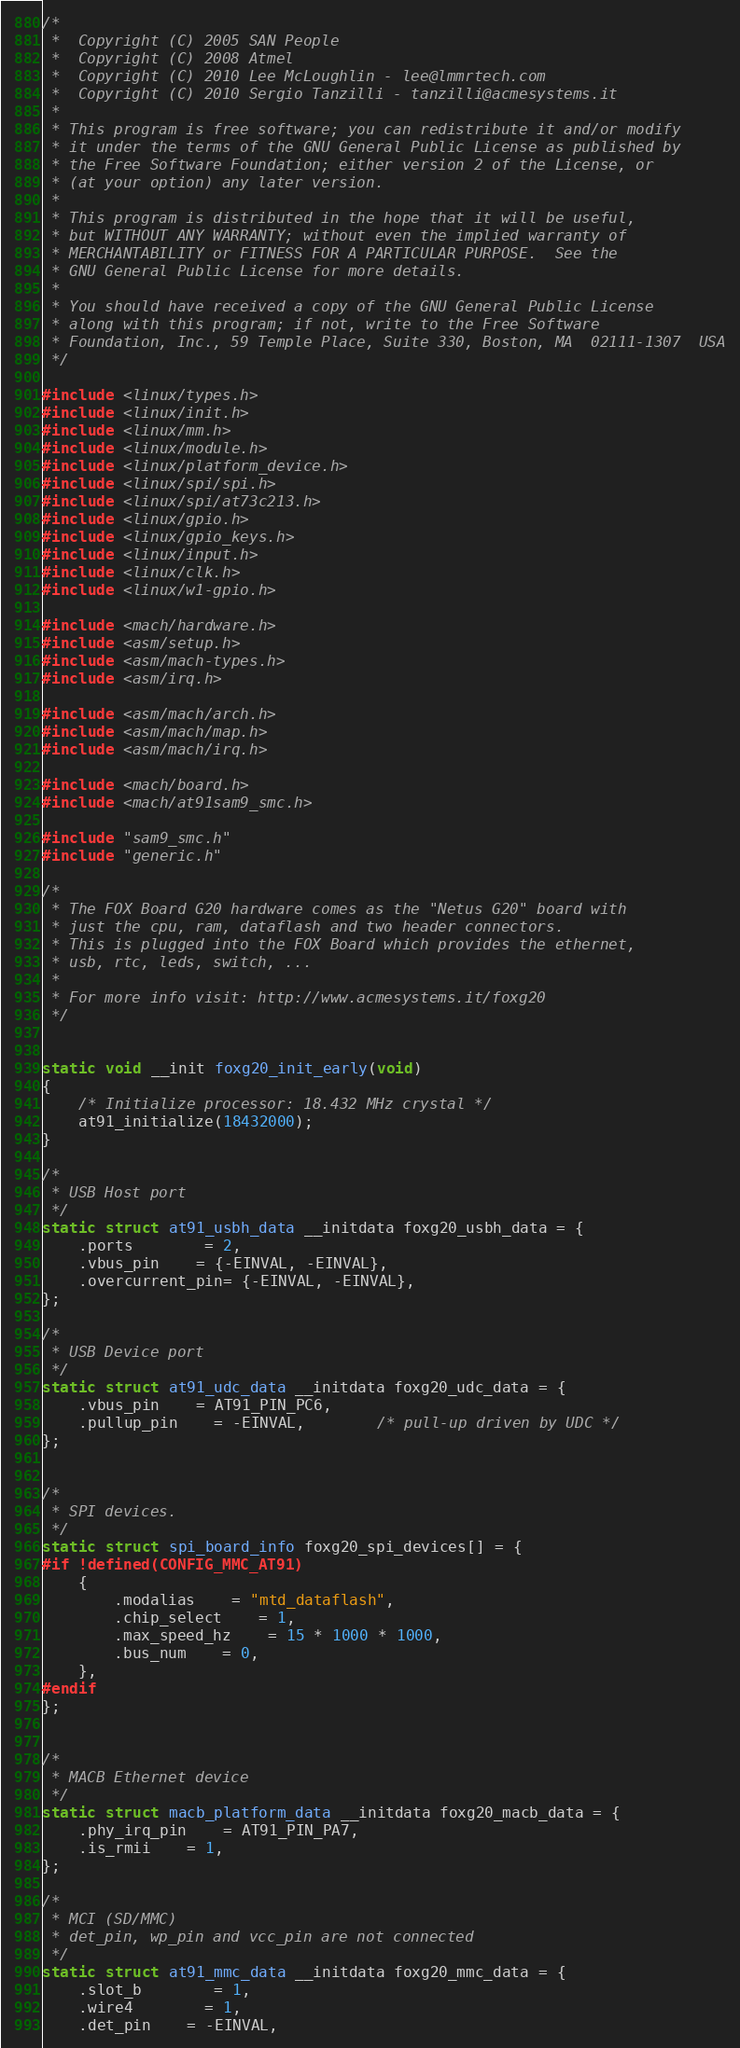<code> <loc_0><loc_0><loc_500><loc_500><_C_>/*
 *  Copyright (C) 2005 SAN People
 *  Copyright (C) 2008 Atmel
 *  Copyright (C) 2010 Lee McLoughlin - lee@lmmrtech.com
 *  Copyright (C) 2010 Sergio Tanzilli - tanzilli@acmesystems.it
 *
 * This program is free software; you can redistribute it and/or modify
 * it under the terms of the GNU General Public License as published by
 * the Free Software Foundation; either version 2 of the License, or
 * (at your option) any later version.
 *
 * This program is distributed in the hope that it will be useful,
 * but WITHOUT ANY WARRANTY; without even the implied warranty of
 * MERCHANTABILITY or FITNESS FOR A PARTICULAR PURPOSE.  See the
 * GNU General Public License for more details.
 *
 * You should have received a copy of the GNU General Public License
 * along with this program; if not, write to the Free Software
 * Foundation, Inc., 59 Temple Place, Suite 330, Boston, MA  02111-1307  USA
 */

#include <linux/types.h>
#include <linux/init.h>
#include <linux/mm.h>
#include <linux/module.h>
#include <linux/platform_device.h>
#include <linux/spi/spi.h>
#include <linux/spi/at73c213.h>
#include <linux/gpio.h>
#include <linux/gpio_keys.h>
#include <linux/input.h>
#include <linux/clk.h>
#include <linux/w1-gpio.h>

#include <mach/hardware.h>
#include <asm/setup.h>
#include <asm/mach-types.h>
#include <asm/irq.h>

#include <asm/mach/arch.h>
#include <asm/mach/map.h>
#include <asm/mach/irq.h>

#include <mach/board.h>
#include <mach/at91sam9_smc.h>

#include "sam9_smc.h"
#include "generic.h"

/*
 * The FOX Board G20 hardware comes as the "Netus G20" board with
 * just the cpu, ram, dataflash and two header connectors.
 * This is plugged into the FOX Board which provides the ethernet,
 * usb, rtc, leds, switch, ...
 *
 * For more info visit: http://www.acmesystems.it/foxg20
 */


static void __init foxg20_init_early(void)
{
	/* Initialize processor: 18.432 MHz crystal */
	at91_initialize(18432000);
}

/*
 * USB Host port
 */
static struct at91_usbh_data __initdata foxg20_usbh_data = {
	.ports		= 2,
	.vbus_pin	= {-EINVAL, -EINVAL},
	.overcurrent_pin= {-EINVAL, -EINVAL},
};

/*
 * USB Device port
 */
static struct at91_udc_data __initdata foxg20_udc_data = {
	.vbus_pin	= AT91_PIN_PC6,
	.pullup_pin	= -EINVAL,		/* pull-up driven by UDC */
};


/*
 * SPI devices.
 */
static struct spi_board_info foxg20_spi_devices[] = {
#if !defined(CONFIG_MMC_AT91)
	{
		.modalias	= "mtd_dataflash",
		.chip_select	= 1,
		.max_speed_hz	= 15 * 1000 * 1000,
		.bus_num	= 0,
	},
#endif
};


/*
 * MACB Ethernet device
 */
static struct macb_platform_data __initdata foxg20_macb_data = {
	.phy_irq_pin	= AT91_PIN_PA7,
	.is_rmii	= 1,
};

/*
 * MCI (SD/MMC)
 * det_pin, wp_pin and vcc_pin are not connected
 */
static struct at91_mmc_data __initdata foxg20_mmc_data = {
	.slot_b		= 1,
	.wire4		= 1,
	.det_pin	= -EINVAL,</code> 